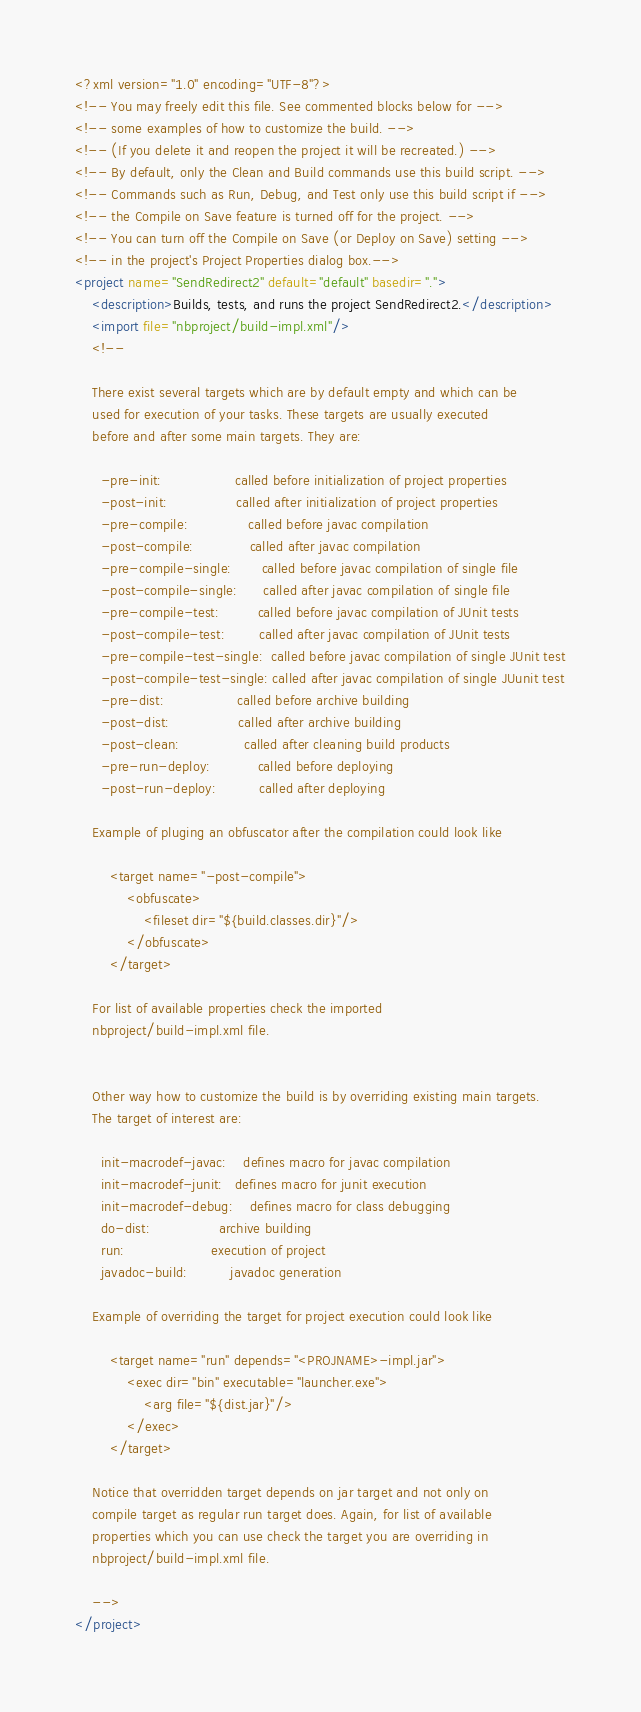Convert code to text. <code><loc_0><loc_0><loc_500><loc_500><_XML_><?xml version="1.0" encoding="UTF-8"?>
<!-- You may freely edit this file. See commented blocks below for -->
<!-- some examples of how to customize the build. -->
<!-- (If you delete it and reopen the project it will be recreated.) -->
<!-- By default, only the Clean and Build commands use this build script. -->
<!-- Commands such as Run, Debug, and Test only use this build script if -->
<!-- the Compile on Save feature is turned off for the project. -->
<!-- You can turn off the Compile on Save (or Deploy on Save) setting -->
<!-- in the project's Project Properties dialog box.-->
<project name="SendRedirect2" default="default" basedir=".">
    <description>Builds, tests, and runs the project SendRedirect2.</description>
    <import file="nbproject/build-impl.xml"/>
    <!--

    There exist several targets which are by default empty and which can be 
    used for execution of your tasks. These targets are usually executed 
    before and after some main targets. They are: 

      -pre-init:                 called before initialization of project properties 
      -post-init:                called after initialization of project properties 
      -pre-compile:              called before javac compilation 
      -post-compile:             called after javac compilation 
      -pre-compile-single:       called before javac compilation of single file
      -post-compile-single:      called after javac compilation of single file
      -pre-compile-test:         called before javac compilation of JUnit tests
      -post-compile-test:        called after javac compilation of JUnit tests
      -pre-compile-test-single:  called before javac compilation of single JUnit test
      -post-compile-test-single: called after javac compilation of single JUunit test
      -pre-dist:                 called before archive building 
      -post-dist:                called after archive building 
      -post-clean:               called after cleaning build products 
      -pre-run-deploy:           called before deploying
      -post-run-deploy:          called after deploying

    Example of pluging an obfuscator after the compilation could look like 

        <target name="-post-compile">
            <obfuscate>
                <fileset dir="${build.classes.dir}"/>
            </obfuscate>
        </target>

    For list of available properties check the imported 
    nbproject/build-impl.xml file. 


    Other way how to customize the build is by overriding existing main targets.
    The target of interest are: 

      init-macrodef-javac:    defines macro for javac compilation
      init-macrodef-junit:   defines macro for junit execution
      init-macrodef-debug:    defines macro for class debugging
      do-dist:                archive building
      run:                    execution of project 
      javadoc-build:          javadoc generation 

    Example of overriding the target for project execution could look like 

        <target name="run" depends="<PROJNAME>-impl.jar">
            <exec dir="bin" executable="launcher.exe">
                <arg file="${dist.jar}"/>
            </exec>
        </target>

    Notice that overridden target depends on jar target and not only on 
    compile target as regular run target does. Again, for list of available 
    properties which you can use check the target you are overriding in 
    nbproject/build-impl.xml file. 

    -->
</project>
</code> 